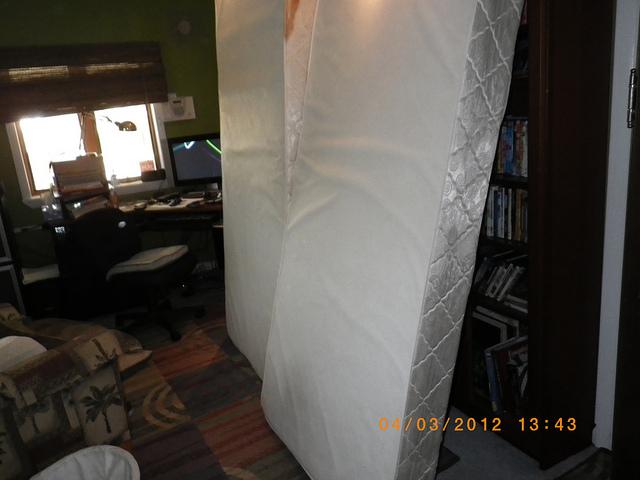Is the bed mattress laying down?
Short answer required. No. What is propped up?
Write a very short answer. Mattress. Where is the cat sleeping?
Write a very short answer. Couch. How many mattresses are there?
Concise answer only. 2. 